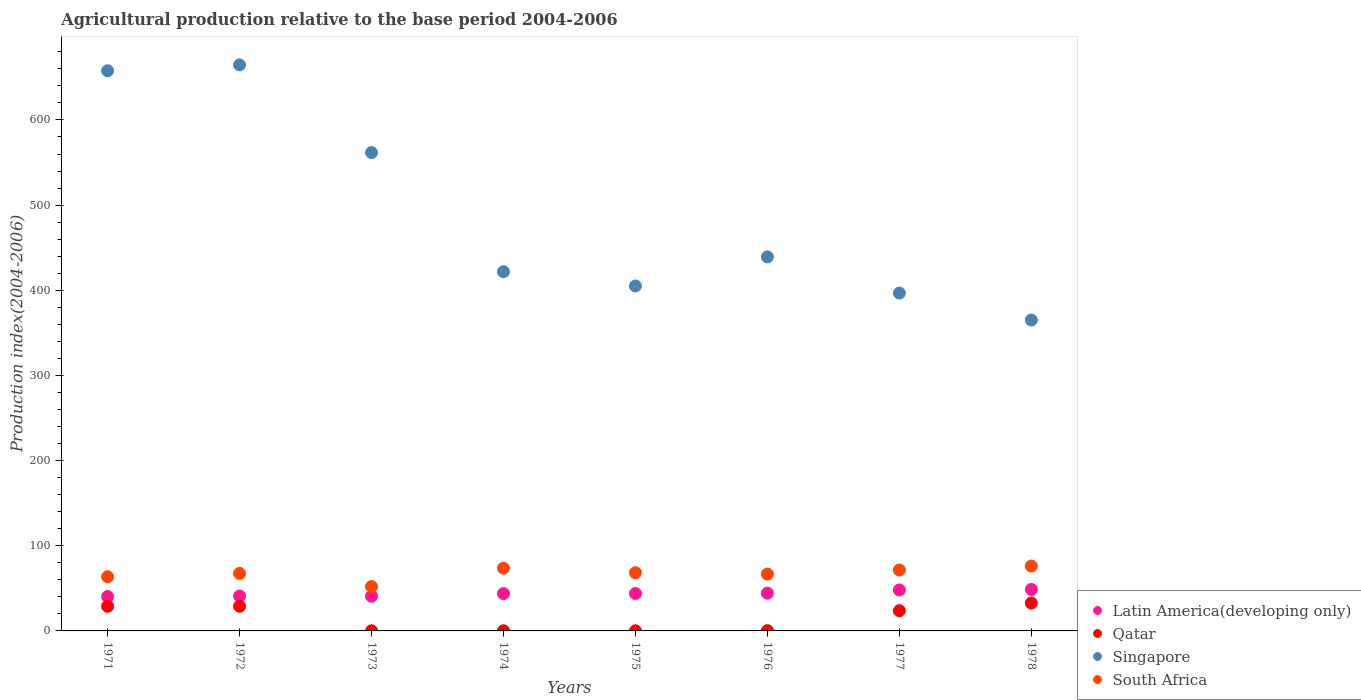How many different coloured dotlines are there?
Give a very brief answer. 4. What is the agricultural production index in South Africa in 1976?
Your answer should be compact. 66.74. Across all years, what is the maximum agricultural production index in Qatar?
Your response must be concise. 32.77. Across all years, what is the minimum agricultural production index in Latin America(developing only)?
Give a very brief answer. 40.36. In which year was the agricultural production index in Qatar maximum?
Provide a succinct answer. 1978. In which year was the agricultural production index in Latin America(developing only) minimum?
Offer a very short reply. 1971. What is the total agricultural production index in Qatar in the graph?
Your response must be concise. 115.3. What is the difference between the agricultural production index in Qatar in 1975 and that in 1978?
Offer a very short reply. -32.57. What is the difference between the agricultural production index in Latin America(developing only) in 1976 and the agricultural production index in Qatar in 1974?
Provide a short and direct response. 44.18. What is the average agricultural production index in Singapore per year?
Offer a very short reply. 489.01. In the year 1972, what is the difference between the agricultural production index in Qatar and agricultural production index in Latin America(developing only)?
Make the answer very short. -12. In how many years, is the agricultural production index in Latin America(developing only) greater than 460?
Your answer should be compact. 0. What is the ratio of the agricultural production index in Qatar in 1971 to that in 1974?
Give a very brief answer. 152.11. Is the agricultural production index in South Africa in 1973 less than that in 1975?
Your answer should be very brief. Yes. Is the difference between the agricultural production index in Qatar in 1976 and 1977 greater than the difference between the agricultural production index in Latin America(developing only) in 1976 and 1977?
Keep it short and to the point. No. What is the difference between the highest and the second highest agricultural production index in Singapore?
Your answer should be very brief. 6.91. What is the difference between the highest and the lowest agricultural production index in Latin America(developing only)?
Provide a short and direct response. 8.34. In how many years, is the agricultural production index in Latin America(developing only) greater than the average agricultural production index in Latin America(developing only) taken over all years?
Offer a terse response. 4. Is it the case that in every year, the sum of the agricultural production index in Qatar and agricultural production index in South Africa  is greater than the sum of agricultural production index in Latin America(developing only) and agricultural production index in Singapore?
Ensure brevity in your answer.  No. Is it the case that in every year, the sum of the agricultural production index in South Africa and agricultural production index in Qatar  is greater than the agricultural production index in Latin America(developing only)?
Make the answer very short. Yes. Does the agricultural production index in Qatar monotonically increase over the years?
Offer a terse response. No. How many years are there in the graph?
Keep it short and to the point. 8. What is the difference between two consecutive major ticks on the Y-axis?
Your response must be concise. 100. How many legend labels are there?
Your answer should be compact. 4. What is the title of the graph?
Provide a short and direct response. Agricultural production relative to the base period 2004-2006. Does "Serbia" appear as one of the legend labels in the graph?
Your answer should be very brief. No. What is the label or title of the Y-axis?
Your response must be concise. Production index(2004-2006). What is the Production index(2004-2006) in Latin America(developing only) in 1971?
Give a very brief answer. 40.36. What is the Production index(2004-2006) in Qatar in 1971?
Your answer should be compact. 28.9. What is the Production index(2004-2006) in Singapore in 1971?
Your answer should be compact. 657.79. What is the Production index(2004-2006) of South Africa in 1971?
Offer a terse response. 63.62. What is the Production index(2004-2006) of Latin America(developing only) in 1972?
Your response must be concise. 40.94. What is the Production index(2004-2006) of Qatar in 1972?
Give a very brief answer. 28.94. What is the Production index(2004-2006) of Singapore in 1972?
Offer a very short reply. 664.7. What is the Production index(2004-2006) of South Africa in 1972?
Your response must be concise. 67.57. What is the Production index(2004-2006) of Latin America(developing only) in 1973?
Offer a very short reply. 40.71. What is the Production index(2004-2006) of Qatar in 1973?
Provide a short and direct response. 0.17. What is the Production index(2004-2006) of Singapore in 1973?
Offer a very short reply. 561.67. What is the Production index(2004-2006) in South Africa in 1973?
Ensure brevity in your answer.  52.07. What is the Production index(2004-2006) of Latin America(developing only) in 1974?
Provide a succinct answer. 43.78. What is the Production index(2004-2006) of Qatar in 1974?
Make the answer very short. 0.19. What is the Production index(2004-2006) of Singapore in 1974?
Offer a terse response. 421.81. What is the Production index(2004-2006) of South Africa in 1974?
Provide a short and direct response. 73.67. What is the Production index(2004-2006) of Latin America(developing only) in 1975?
Your answer should be compact. 43.99. What is the Production index(2004-2006) of Singapore in 1975?
Offer a terse response. 405.08. What is the Production index(2004-2006) of South Africa in 1975?
Offer a terse response. 68.36. What is the Production index(2004-2006) in Latin America(developing only) in 1976?
Give a very brief answer. 44.37. What is the Production index(2004-2006) of Qatar in 1976?
Provide a short and direct response. 0.36. What is the Production index(2004-2006) of Singapore in 1976?
Provide a succinct answer. 439.22. What is the Production index(2004-2006) in South Africa in 1976?
Keep it short and to the point. 66.74. What is the Production index(2004-2006) of Latin America(developing only) in 1977?
Offer a terse response. 48.1. What is the Production index(2004-2006) of Qatar in 1977?
Offer a terse response. 23.77. What is the Production index(2004-2006) in Singapore in 1977?
Keep it short and to the point. 396.72. What is the Production index(2004-2006) of South Africa in 1977?
Your answer should be very brief. 71.51. What is the Production index(2004-2006) of Latin America(developing only) in 1978?
Keep it short and to the point. 48.69. What is the Production index(2004-2006) of Qatar in 1978?
Provide a succinct answer. 32.77. What is the Production index(2004-2006) of Singapore in 1978?
Your answer should be compact. 365.07. What is the Production index(2004-2006) in South Africa in 1978?
Ensure brevity in your answer.  76.16. Across all years, what is the maximum Production index(2004-2006) in Latin America(developing only)?
Provide a short and direct response. 48.69. Across all years, what is the maximum Production index(2004-2006) of Qatar?
Your answer should be very brief. 32.77. Across all years, what is the maximum Production index(2004-2006) of Singapore?
Ensure brevity in your answer.  664.7. Across all years, what is the maximum Production index(2004-2006) of South Africa?
Offer a terse response. 76.16. Across all years, what is the minimum Production index(2004-2006) of Latin America(developing only)?
Give a very brief answer. 40.36. Across all years, what is the minimum Production index(2004-2006) in Qatar?
Provide a short and direct response. 0.17. Across all years, what is the minimum Production index(2004-2006) in Singapore?
Your answer should be compact. 365.07. Across all years, what is the minimum Production index(2004-2006) of South Africa?
Your answer should be very brief. 52.07. What is the total Production index(2004-2006) in Latin America(developing only) in the graph?
Provide a short and direct response. 350.93. What is the total Production index(2004-2006) of Qatar in the graph?
Ensure brevity in your answer.  115.3. What is the total Production index(2004-2006) in Singapore in the graph?
Offer a terse response. 3912.06. What is the total Production index(2004-2006) of South Africa in the graph?
Your answer should be very brief. 539.7. What is the difference between the Production index(2004-2006) in Latin America(developing only) in 1971 and that in 1972?
Keep it short and to the point. -0.59. What is the difference between the Production index(2004-2006) of Qatar in 1971 and that in 1972?
Your answer should be compact. -0.04. What is the difference between the Production index(2004-2006) in Singapore in 1971 and that in 1972?
Make the answer very short. -6.91. What is the difference between the Production index(2004-2006) in South Africa in 1971 and that in 1972?
Ensure brevity in your answer.  -3.95. What is the difference between the Production index(2004-2006) of Latin America(developing only) in 1971 and that in 1973?
Make the answer very short. -0.35. What is the difference between the Production index(2004-2006) in Qatar in 1971 and that in 1973?
Make the answer very short. 28.73. What is the difference between the Production index(2004-2006) of Singapore in 1971 and that in 1973?
Your answer should be compact. 96.12. What is the difference between the Production index(2004-2006) of South Africa in 1971 and that in 1973?
Keep it short and to the point. 11.55. What is the difference between the Production index(2004-2006) in Latin America(developing only) in 1971 and that in 1974?
Offer a very short reply. -3.42. What is the difference between the Production index(2004-2006) in Qatar in 1971 and that in 1974?
Offer a very short reply. 28.71. What is the difference between the Production index(2004-2006) of Singapore in 1971 and that in 1974?
Give a very brief answer. 235.98. What is the difference between the Production index(2004-2006) of South Africa in 1971 and that in 1974?
Provide a short and direct response. -10.05. What is the difference between the Production index(2004-2006) of Latin America(developing only) in 1971 and that in 1975?
Offer a very short reply. -3.64. What is the difference between the Production index(2004-2006) of Qatar in 1971 and that in 1975?
Provide a succinct answer. 28.7. What is the difference between the Production index(2004-2006) of Singapore in 1971 and that in 1975?
Your answer should be very brief. 252.71. What is the difference between the Production index(2004-2006) in South Africa in 1971 and that in 1975?
Offer a terse response. -4.74. What is the difference between the Production index(2004-2006) in Latin America(developing only) in 1971 and that in 1976?
Offer a terse response. -4.01. What is the difference between the Production index(2004-2006) in Qatar in 1971 and that in 1976?
Your response must be concise. 28.54. What is the difference between the Production index(2004-2006) in Singapore in 1971 and that in 1976?
Offer a terse response. 218.57. What is the difference between the Production index(2004-2006) of South Africa in 1971 and that in 1976?
Offer a very short reply. -3.12. What is the difference between the Production index(2004-2006) in Latin America(developing only) in 1971 and that in 1977?
Provide a short and direct response. -7.74. What is the difference between the Production index(2004-2006) of Qatar in 1971 and that in 1977?
Your answer should be very brief. 5.13. What is the difference between the Production index(2004-2006) in Singapore in 1971 and that in 1977?
Keep it short and to the point. 261.07. What is the difference between the Production index(2004-2006) of South Africa in 1971 and that in 1977?
Give a very brief answer. -7.89. What is the difference between the Production index(2004-2006) in Latin America(developing only) in 1971 and that in 1978?
Ensure brevity in your answer.  -8.34. What is the difference between the Production index(2004-2006) of Qatar in 1971 and that in 1978?
Your response must be concise. -3.87. What is the difference between the Production index(2004-2006) in Singapore in 1971 and that in 1978?
Offer a very short reply. 292.72. What is the difference between the Production index(2004-2006) of South Africa in 1971 and that in 1978?
Your response must be concise. -12.54. What is the difference between the Production index(2004-2006) of Latin America(developing only) in 1972 and that in 1973?
Ensure brevity in your answer.  0.24. What is the difference between the Production index(2004-2006) of Qatar in 1972 and that in 1973?
Ensure brevity in your answer.  28.77. What is the difference between the Production index(2004-2006) of Singapore in 1972 and that in 1973?
Offer a very short reply. 103.03. What is the difference between the Production index(2004-2006) in Latin America(developing only) in 1972 and that in 1974?
Give a very brief answer. -2.83. What is the difference between the Production index(2004-2006) in Qatar in 1972 and that in 1974?
Ensure brevity in your answer.  28.75. What is the difference between the Production index(2004-2006) in Singapore in 1972 and that in 1974?
Ensure brevity in your answer.  242.89. What is the difference between the Production index(2004-2006) of South Africa in 1972 and that in 1974?
Keep it short and to the point. -6.1. What is the difference between the Production index(2004-2006) of Latin America(developing only) in 1972 and that in 1975?
Provide a short and direct response. -3.05. What is the difference between the Production index(2004-2006) of Qatar in 1972 and that in 1975?
Give a very brief answer. 28.74. What is the difference between the Production index(2004-2006) of Singapore in 1972 and that in 1975?
Ensure brevity in your answer.  259.62. What is the difference between the Production index(2004-2006) in South Africa in 1972 and that in 1975?
Ensure brevity in your answer.  -0.79. What is the difference between the Production index(2004-2006) of Latin America(developing only) in 1972 and that in 1976?
Keep it short and to the point. -3.42. What is the difference between the Production index(2004-2006) of Qatar in 1972 and that in 1976?
Give a very brief answer. 28.58. What is the difference between the Production index(2004-2006) of Singapore in 1972 and that in 1976?
Make the answer very short. 225.48. What is the difference between the Production index(2004-2006) of South Africa in 1972 and that in 1976?
Give a very brief answer. 0.83. What is the difference between the Production index(2004-2006) in Latin America(developing only) in 1972 and that in 1977?
Your response must be concise. -7.16. What is the difference between the Production index(2004-2006) in Qatar in 1972 and that in 1977?
Keep it short and to the point. 5.17. What is the difference between the Production index(2004-2006) in Singapore in 1972 and that in 1977?
Your answer should be compact. 267.98. What is the difference between the Production index(2004-2006) in South Africa in 1972 and that in 1977?
Your answer should be compact. -3.94. What is the difference between the Production index(2004-2006) in Latin America(developing only) in 1972 and that in 1978?
Make the answer very short. -7.75. What is the difference between the Production index(2004-2006) of Qatar in 1972 and that in 1978?
Make the answer very short. -3.83. What is the difference between the Production index(2004-2006) in Singapore in 1972 and that in 1978?
Give a very brief answer. 299.63. What is the difference between the Production index(2004-2006) in South Africa in 1972 and that in 1978?
Make the answer very short. -8.59. What is the difference between the Production index(2004-2006) in Latin America(developing only) in 1973 and that in 1974?
Provide a short and direct response. -3.07. What is the difference between the Production index(2004-2006) of Qatar in 1973 and that in 1974?
Ensure brevity in your answer.  -0.02. What is the difference between the Production index(2004-2006) in Singapore in 1973 and that in 1974?
Your response must be concise. 139.86. What is the difference between the Production index(2004-2006) of South Africa in 1973 and that in 1974?
Provide a succinct answer. -21.6. What is the difference between the Production index(2004-2006) of Latin America(developing only) in 1973 and that in 1975?
Provide a short and direct response. -3.28. What is the difference between the Production index(2004-2006) of Qatar in 1973 and that in 1975?
Make the answer very short. -0.03. What is the difference between the Production index(2004-2006) in Singapore in 1973 and that in 1975?
Ensure brevity in your answer.  156.59. What is the difference between the Production index(2004-2006) of South Africa in 1973 and that in 1975?
Offer a terse response. -16.29. What is the difference between the Production index(2004-2006) in Latin America(developing only) in 1973 and that in 1976?
Your answer should be very brief. -3.66. What is the difference between the Production index(2004-2006) in Qatar in 1973 and that in 1976?
Provide a short and direct response. -0.19. What is the difference between the Production index(2004-2006) in Singapore in 1973 and that in 1976?
Your response must be concise. 122.45. What is the difference between the Production index(2004-2006) in South Africa in 1973 and that in 1976?
Keep it short and to the point. -14.67. What is the difference between the Production index(2004-2006) of Latin America(developing only) in 1973 and that in 1977?
Make the answer very short. -7.39. What is the difference between the Production index(2004-2006) of Qatar in 1973 and that in 1977?
Provide a short and direct response. -23.6. What is the difference between the Production index(2004-2006) in Singapore in 1973 and that in 1977?
Your answer should be compact. 164.95. What is the difference between the Production index(2004-2006) of South Africa in 1973 and that in 1977?
Provide a short and direct response. -19.44. What is the difference between the Production index(2004-2006) of Latin America(developing only) in 1973 and that in 1978?
Make the answer very short. -7.99. What is the difference between the Production index(2004-2006) in Qatar in 1973 and that in 1978?
Your response must be concise. -32.6. What is the difference between the Production index(2004-2006) of Singapore in 1973 and that in 1978?
Give a very brief answer. 196.6. What is the difference between the Production index(2004-2006) in South Africa in 1973 and that in 1978?
Offer a very short reply. -24.09. What is the difference between the Production index(2004-2006) of Latin America(developing only) in 1974 and that in 1975?
Offer a very short reply. -0.22. What is the difference between the Production index(2004-2006) in Qatar in 1974 and that in 1975?
Provide a succinct answer. -0.01. What is the difference between the Production index(2004-2006) of Singapore in 1974 and that in 1975?
Your answer should be compact. 16.73. What is the difference between the Production index(2004-2006) in South Africa in 1974 and that in 1975?
Provide a succinct answer. 5.31. What is the difference between the Production index(2004-2006) of Latin America(developing only) in 1974 and that in 1976?
Your response must be concise. -0.59. What is the difference between the Production index(2004-2006) in Qatar in 1974 and that in 1976?
Keep it short and to the point. -0.17. What is the difference between the Production index(2004-2006) of Singapore in 1974 and that in 1976?
Offer a terse response. -17.41. What is the difference between the Production index(2004-2006) in South Africa in 1974 and that in 1976?
Give a very brief answer. 6.93. What is the difference between the Production index(2004-2006) of Latin America(developing only) in 1974 and that in 1977?
Give a very brief answer. -4.32. What is the difference between the Production index(2004-2006) of Qatar in 1974 and that in 1977?
Offer a very short reply. -23.58. What is the difference between the Production index(2004-2006) in Singapore in 1974 and that in 1977?
Provide a succinct answer. 25.09. What is the difference between the Production index(2004-2006) in South Africa in 1974 and that in 1977?
Your response must be concise. 2.16. What is the difference between the Production index(2004-2006) of Latin America(developing only) in 1974 and that in 1978?
Provide a short and direct response. -4.92. What is the difference between the Production index(2004-2006) in Qatar in 1974 and that in 1978?
Ensure brevity in your answer.  -32.58. What is the difference between the Production index(2004-2006) in Singapore in 1974 and that in 1978?
Provide a short and direct response. 56.74. What is the difference between the Production index(2004-2006) in South Africa in 1974 and that in 1978?
Your answer should be very brief. -2.49. What is the difference between the Production index(2004-2006) of Latin America(developing only) in 1975 and that in 1976?
Give a very brief answer. -0.37. What is the difference between the Production index(2004-2006) of Qatar in 1975 and that in 1976?
Ensure brevity in your answer.  -0.16. What is the difference between the Production index(2004-2006) in Singapore in 1975 and that in 1976?
Ensure brevity in your answer.  -34.14. What is the difference between the Production index(2004-2006) of South Africa in 1975 and that in 1976?
Make the answer very short. 1.62. What is the difference between the Production index(2004-2006) in Latin America(developing only) in 1975 and that in 1977?
Your response must be concise. -4.11. What is the difference between the Production index(2004-2006) of Qatar in 1975 and that in 1977?
Offer a very short reply. -23.57. What is the difference between the Production index(2004-2006) of Singapore in 1975 and that in 1977?
Offer a terse response. 8.36. What is the difference between the Production index(2004-2006) in South Africa in 1975 and that in 1977?
Ensure brevity in your answer.  -3.15. What is the difference between the Production index(2004-2006) in Latin America(developing only) in 1975 and that in 1978?
Make the answer very short. -4.7. What is the difference between the Production index(2004-2006) of Qatar in 1975 and that in 1978?
Your response must be concise. -32.57. What is the difference between the Production index(2004-2006) in Singapore in 1975 and that in 1978?
Make the answer very short. 40.01. What is the difference between the Production index(2004-2006) of South Africa in 1975 and that in 1978?
Your answer should be compact. -7.8. What is the difference between the Production index(2004-2006) of Latin America(developing only) in 1976 and that in 1977?
Provide a succinct answer. -3.73. What is the difference between the Production index(2004-2006) of Qatar in 1976 and that in 1977?
Offer a terse response. -23.41. What is the difference between the Production index(2004-2006) in Singapore in 1976 and that in 1977?
Provide a succinct answer. 42.5. What is the difference between the Production index(2004-2006) of South Africa in 1976 and that in 1977?
Give a very brief answer. -4.77. What is the difference between the Production index(2004-2006) of Latin America(developing only) in 1976 and that in 1978?
Offer a very short reply. -4.33. What is the difference between the Production index(2004-2006) in Qatar in 1976 and that in 1978?
Your answer should be compact. -32.41. What is the difference between the Production index(2004-2006) in Singapore in 1976 and that in 1978?
Offer a very short reply. 74.15. What is the difference between the Production index(2004-2006) in South Africa in 1976 and that in 1978?
Keep it short and to the point. -9.42. What is the difference between the Production index(2004-2006) in Latin America(developing only) in 1977 and that in 1978?
Make the answer very short. -0.6. What is the difference between the Production index(2004-2006) of Singapore in 1977 and that in 1978?
Provide a succinct answer. 31.65. What is the difference between the Production index(2004-2006) in South Africa in 1977 and that in 1978?
Offer a very short reply. -4.65. What is the difference between the Production index(2004-2006) of Latin America(developing only) in 1971 and the Production index(2004-2006) of Qatar in 1972?
Keep it short and to the point. 11.42. What is the difference between the Production index(2004-2006) of Latin America(developing only) in 1971 and the Production index(2004-2006) of Singapore in 1972?
Ensure brevity in your answer.  -624.34. What is the difference between the Production index(2004-2006) in Latin America(developing only) in 1971 and the Production index(2004-2006) in South Africa in 1972?
Provide a short and direct response. -27.21. What is the difference between the Production index(2004-2006) in Qatar in 1971 and the Production index(2004-2006) in Singapore in 1972?
Provide a short and direct response. -635.8. What is the difference between the Production index(2004-2006) in Qatar in 1971 and the Production index(2004-2006) in South Africa in 1972?
Your response must be concise. -38.67. What is the difference between the Production index(2004-2006) of Singapore in 1971 and the Production index(2004-2006) of South Africa in 1972?
Your answer should be very brief. 590.22. What is the difference between the Production index(2004-2006) of Latin America(developing only) in 1971 and the Production index(2004-2006) of Qatar in 1973?
Make the answer very short. 40.19. What is the difference between the Production index(2004-2006) in Latin America(developing only) in 1971 and the Production index(2004-2006) in Singapore in 1973?
Your answer should be compact. -521.31. What is the difference between the Production index(2004-2006) of Latin America(developing only) in 1971 and the Production index(2004-2006) of South Africa in 1973?
Offer a very short reply. -11.71. What is the difference between the Production index(2004-2006) in Qatar in 1971 and the Production index(2004-2006) in Singapore in 1973?
Ensure brevity in your answer.  -532.77. What is the difference between the Production index(2004-2006) of Qatar in 1971 and the Production index(2004-2006) of South Africa in 1973?
Make the answer very short. -23.17. What is the difference between the Production index(2004-2006) in Singapore in 1971 and the Production index(2004-2006) in South Africa in 1973?
Make the answer very short. 605.72. What is the difference between the Production index(2004-2006) in Latin America(developing only) in 1971 and the Production index(2004-2006) in Qatar in 1974?
Keep it short and to the point. 40.17. What is the difference between the Production index(2004-2006) in Latin America(developing only) in 1971 and the Production index(2004-2006) in Singapore in 1974?
Your response must be concise. -381.45. What is the difference between the Production index(2004-2006) of Latin America(developing only) in 1971 and the Production index(2004-2006) of South Africa in 1974?
Keep it short and to the point. -33.31. What is the difference between the Production index(2004-2006) in Qatar in 1971 and the Production index(2004-2006) in Singapore in 1974?
Offer a terse response. -392.91. What is the difference between the Production index(2004-2006) in Qatar in 1971 and the Production index(2004-2006) in South Africa in 1974?
Provide a succinct answer. -44.77. What is the difference between the Production index(2004-2006) in Singapore in 1971 and the Production index(2004-2006) in South Africa in 1974?
Give a very brief answer. 584.12. What is the difference between the Production index(2004-2006) in Latin America(developing only) in 1971 and the Production index(2004-2006) in Qatar in 1975?
Your response must be concise. 40.16. What is the difference between the Production index(2004-2006) of Latin America(developing only) in 1971 and the Production index(2004-2006) of Singapore in 1975?
Provide a succinct answer. -364.72. What is the difference between the Production index(2004-2006) in Latin America(developing only) in 1971 and the Production index(2004-2006) in South Africa in 1975?
Your answer should be very brief. -28. What is the difference between the Production index(2004-2006) of Qatar in 1971 and the Production index(2004-2006) of Singapore in 1975?
Your response must be concise. -376.18. What is the difference between the Production index(2004-2006) of Qatar in 1971 and the Production index(2004-2006) of South Africa in 1975?
Offer a very short reply. -39.46. What is the difference between the Production index(2004-2006) of Singapore in 1971 and the Production index(2004-2006) of South Africa in 1975?
Make the answer very short. 589.43. What is the difference between the Production index(2004-2006) in Latin America(developing only) in 1971 and the Production index(2004-2006) in Qatar in 1976?
Make the answer very short. 40. What is the difference between the Production index(2004-2006) of Latin America(developing only) in 1971 and the Production index(2004-2006) of Singapore in 1976?
Keep it short and to the point. -398.86. What is the difference between the Production index(2004-2006) in Latin America(developing only) in 1971 and the Production index(2004-2006) in South Africa in 1976?
Offer a terse response. -26.38. What is the difference between the Production index(2004-2006) of Qatar in 1971 and the Production index(2004-2006) of Singapore in 1976?
Keep it short and to the point. -410.32. What is the difference between the Production index(2004-2006) in Qatar in 1971 and the Production index(2004-2006) in South Africa in 1976?
Ensure brevity in your answer.  -37.84. What is the difference between the Production index(2004-2006) in Singapore in 1971 and the Production index(2004-2006) in South Africa in 1976?
Offer a terse response. 591.05. What is the difference between the Production index(2004-2006) in Latin America(developing only) in 1971 and the Production index(2004-2006) in Qatar in 1977?
Your answer should be compact. 16.59. What is the difference between the Production index(2004-2006) in Latin America(developing only) in 1971 and the Production index(2004-2006) in Singapore in 1977?
Offer a terse response. -356.36. What is the difference between the Production index(2004-2006) of Latin America(developing only) in 1971 and the Production index(2004-2006) of South Africa in 1977?
Provide a short and direct response. -31.15. What is the difference between the Production index(2004-2006) of Qatar in 1971 and the Production index(2004-2006) of Singapore in 1977?
Keep it short and to the point. -367.82. What is the difference between the Production index(2004-2006) of Qatar in 1971 and the Production index(2004-2006) of South Africa in 1977?
Make the answer very short. -42.61. What is the difference between the Production index(2004-2006) in Singapore in 1971 and the Production index(2004-2006) in South Africa in 1977?
Make the answer very short. 586.28. What is the difference between the Production index(2004-2006) in Latin America(developing only) in 1971 and the Production index(2004-2006) in Qatar in 1978?
Provide a succinct answer. 7.59. What is the difference between the Production index(2004-2006) of Latin America(developing only) in 1971 and the Production index(2004-2006) of Singapore in 1978?
Give a very brief answer. -324.71. What is the difference between the Production index(2004-2006) in Latin America(developing only) in 1971 and the Production index(2004-2006) in South Africa in 1978?
Ensure brevity in your answer.  -35.8. What is the difference between the Production index(2004-2006) in Qatar in 1971 and the Production index(2004-2006) in Singapore in 1978?
Make the answer very short. -336.17. What is the difference between the Production index(2004-2006) in Qatar in 1971 and the Production index(2004-2006) in South Africa in 1978?
Provide a short and direct response. -47.26. What is the difference between the Production index(2004-2006) in Singapore in 1971 and the Production index(2004-2006) in South Africa in 1978?
Your response must be concise. 581.63. What is the difference between the Production index(2004-2006) in Latin America(developing only) in 1972 and the Production index(2004-2006) in Qatar in 1973?
Give a very brief answer. 40.77. What is the difference between the Production index(2004-2006) of Latin America(developing only) in 1972 and the Production index(2004-2006) of Singapore in 1973?
Offer a very short reply. -520.73. What is the difference between the Production index(2004-2006) in Latin America(developing only) in 1972 and the Production index(2004-2006) in South Africa in 1973?
Give a very brief answer. -11.13. What is the difference between the Production index(2004-2006) in Qatar in 1972 and the Production index(2004-2006) in Singapore in 1973?
Your answer should be very brief. -532.73. What is the difference between the Production index(2004-2006) of Qatar in 1972 and the Production index(2004-2006) of South Africa in 1973?
Your answer should be compact. -23.13. What is the difference between the Production index(2004-2006) of Singapore in 1972 and the Production index(2004-2006) of South Africa in 1973?
Give a very brief answer. 612.63. What is the difference between the Production index(2004-2006) in Latin America(developing only) in 1972 and the Production index(2004-2006) in Qatar in 1974?
Provide a succinct answer. 40.75. What is the difference between the Production index(2004-2006) in Latin America(developing only) in 1972 and the Production index(2004-2006) in Singapore in 1974?
Your response must be concise. -380.87. What is the difference between the Production index(2004-2006) in Latin America(developing only) in 1972 and the Production index(2004-2006) in South Africa in 1974?
Give a very brief answer. -32.73. What is the difference between the Production index(2004-2006) of Qatar in 1972 and the Production index(2004-2006) of Singapore in 1974?
Your answer should be very brief. -392.87. What is the difference between the Production index(2004-2006) of Qatar in 1972 and the Production index(2004-2006) of South Africa in 1974?
Your answer should be very brief. -44.73. What is the difference between the Production index(2004-2006) of Singapore in 1972 and the Production index(2004-2006) of South Africa in 1974?
Your answer should be compact. 591.03. What is the difference between the Production index(2004-2006) of Latin America(developing only) in 1972 and the Production index(2004-2006) of Qatar in 1975?
Give a very brief answer. 40.74. What is the difference between the Production index(2004-2006) in Latin America(developing only) in 1972 and the Production index(2004-2006) in Singapore in 1975?
Provide a succinct answer. -364.14. What is the difference between the Production index(2004-2006) in Latin America(developing only) in 1972 and the Production index(2004-2006) in South Africa in 1975?
Your answer should be very brief. -27.42. What is the difference between the Production index(2004-2006) in Qatar in 1972 and the Production index(2004-2006) in Singapore in 1975?
Provide a succinct answer. -376.14. What is the difference between the Production index(2004-2006) in Qatar in 1972 and the Production index(2004-2006) in South Africa in 1975?
Your answer should be compact. -39.42. What is the difference between the Production index(2004-2006) in Singapore in 1972 and the Production index(2004-2006) in South Africa in 1975?
Ensure brevity in your answer.  596.34. What is the difference between the Production index(2004-2006) of Latin America(developing only) in 1972 and the Production index(2004-2006) of Qatar in 1976?
Provide a short and direct response. 40.58. What is the difference between the Production index(2004-2006) of Latin America(developing only) in 1972 and the Production index(2004-2006) of Singapore in 1976?
Offer a terse response. -398.28. What is the difference between the Production index(2004-2006) in Latin America(developing only) in 1972 and the Production index(2004-2006) in South Africa in 1976?
Your answer should be very brief. -25.8. What is the difference between the Production index(2004-2006) of Qatar in 1972 and the Production index(2004-2006) of Singapore in 1976?
Offer a terse response. -410.28. What is the difference between the Production index(2004-2006) in Qatar in 1972 and the Production index(2004-2006) in South Africa in 1976?
Your response must be concise. -37.8. What is the difference between the Production index(2004-2006) in Singapore in 1972 and the Production index(2004-2006) in South Africa in 1976?
Make the answer very short. 597.96. What is the difference between the Production index(2004-2006) in Latin America(developing only) in 1972 and the Production index(2004-2006) in Qatar in 1977?
Your response must be concise. 17.17. What is the difference between the Production index(2004-2006) of Latin America(developing only) in 1972 and the Production index(2004-2006) of Singapore in 1977?
Give a very brief answer. -355.78. What is the difference between the Production index(2004-2006) in Latin America(developing only) in 1972 and the Production index(2004-2006) in South Africa in 1977?
Give a very brief answer. -30.57. What is the difference between the Production index(2004-2006) of Qatar in 1972 and the Production index(2004-2006) of Singapore in 1977?
Provide a succinct answer. -367.78. What is the difference between the Production index(2004-2006) in Qatar in 1972 and the Production index(2004-2006) in South Africa in 1977?
Give a very brief answer. -42.57. What is the difference between the Production index(2004-2006) of Singapore in 1972 and the Production index(2004-2006) of South Africa in 1977?
Your answer should be very brief. 593.19. What is the difference between the Production index(2004-2006) of Latin America(developing only) in 1972 and the Production index(2004-2006) of Qatar in 1978?
Keep it short and to the point. 8.17. What is the difference between the Production index(2004-2006) of Latin America(developing only) in 1972 and the Production index(2004-2006) of Singapore in 1978?
Your answer should be compact. -324.13. What is the difference between the Production index(2004-2006) in Latin America(developing only) in 1972 and the Production index(2004-2006) in South Africa in 1978?
Offer a terse response. -35.22. What is the difference between the Production index(2004-2006) in Qatar in 1972 and the Production index(2004-2006) in Singapore in 1978?
Offer a very short reply. -336.13. What is the difference between the Production index(2004-2006) of Qatar in 1972 and the Production index(2004-2006) of South Africa in 1978?
Offer a very short reply. -47.22. What is the difference between the Production index(2004-2006) of Singapore in 1972 and the Production index(2004-2006) of South Africa in 1978?
Your response must be concise. 588.54. What is the difference between the Production index(2004-2006) of Latin America(developing only) in 1973 and the Production index(2004-2006) of Qatar in 1974?
Give a very brief answer. 40.52. What is the difference between the Production index(2004-2006) of Latin America(developing only) in 1973 and the Production index(2004-2006) of Singapore in 1974?
Ensure brevity in your answer.  -381.1. What is the difference between the Production index(2004-2006) in Latin America(developing only) in 1973 and the Production index(2004-2006) in South Africa in 1974?
Provide a succinct answer. -32.96. What is the difference between the Production index(2004-2006) in Qatar in 1973 and the Production index(2004-2006) in Singapore in 1974?
Give a very brief answer. -421.64. What is the difference between the Production index(2004-2006) of Qatar in 1973 and the Production index(2004-2006) of South Africa in 1974?
Your answer should be very brief. -73.5. What is the difference between the Production index(2004-2006) of Singapore in 1973 and the Production index(2004-2006) of South Africa in 1974?
Provide a short and direct response. 488. What is the difference between the Production index(2004-2006) of Latin America(developing only) in 1973 and the Production index(2004-2006) of Qatar in 1975?
Offer a very short reply. 40.51. What is the difference between the Production index(2004-2006) in Latin America(developing only) in 1973 and the Production index(2004-2006) in Singapore in 1975?
Ensure brevity in your answer.  -364.37. What is the difference between the Production index(2004-2006) in Latin America(developing only) in 1973 and the Production index(2004-2006) in South Africa in 1975?
Ensure brevity in your answer.  -27.65. What is the difference between the Production index(2004-2006) in Qatar in 1973 and the Production index(2004-2006) in Singapore in 1975?
Ensure brevity in your answer.  -404.91. What is the difference between the Production index(2004-2006) in Qatar in 1973 and the Production index(2004-2006) in South Africa in 1975?
Offer a very short reply. -68.19. What is the difference between the Production index(2004-2006) in Singapore in 1973 and the Production index(2004-2006) in South Africa in 1975?
Provide a succinct answer. 493.31. What is the difference between the Production index(2004-2006) in Latin America(developing only) in 1973 and the Production index(2004-2006) in Qatar in 1976?
Ensure brevity in your answer.  40.35. What is the difference between the Production index(2004-2006) in Latin America(developing only) in 1973 and the Production index(2004-2006) in Singapore in 1976?
Offer a terse response. -398.51. What is the difference between the Production index(2004-2006) in Latin America(developing only) in 1973 and the Production index(2004-2006) in South Africa in 1976?
Provide a short and direct response. -26.03. What is the difference between the Production index(2004-2006) in Qatar in 1973 and the Production index(2004-2006) in Singapore in 1976?
Give a very brief answer. -439.05. What is the difference between the Production index(2004-2006) of Qatar in 1973 and the Production index(2004-2006) of South Africa in 1976?
Give a very brief answer. -66.57. What is the difference between the Production index(2004-2006) of Singapore in 1973 and the Production index(2004-2006) of South Africa in 1976?
Provide a succinct answer. 494.93. What is the difference between the Production index(2004-2006) of Latin America(developing only) in 1973 and the Production index(2004-2006) of Qatar in 1977?
Give a very brief answer. 16.94. What is the difference between the Production index(2004-2006) of Latin America(developing only) in 1973 and the Production index(2004-2006) of Singapore in 1977?
Keep it short and to the point. -356.01. What is the difference between the Production index(2004-2006) in Latin America(developing only) in 1973 and the Production index(2004-2006) in South Africa in 1977?
Offer a terse response. -30.8. What is the difference between the Production index(2004-2006) in Qatar in 1973 and the Production index(2004-2006) in Singapore in 1977?
Provide a succinct answer. -396.55. What is the difference between the Production index(2004-2006) of Qatar in 1973 and the Production index(2004-2006) of South Africa in 1977?
Your response must be concise. -71.34. What is the difference between the Production index(2004-2006) in Singapore in 1973 and the Production index(2004-2006) in South Africa in 1977?
Your response must be concise. 490.16. What is the difference between the Production index(2004-2006) of Latin America(developing only) in 1973 and the Production index(2004-2006) of Qatar in 1978?
Make the answer very short. 7.94. What is the difference between the Production index(2004-2006) of Latin America(developing only) in 1973 and the Production index(2004-2006) of Singapore in 1978?
Your answer should be very brief. -324.36. What is the difference between the Production index(2004-2006) of Latin America(developing only) in 1973 and the Production index(2004-2006) of South Africa in 1978?
Keep it short and to the point. -35.45. What is the difference between the Production index(2004-2006) of Qatar in 1973 and the Production index(2004-2006) of Singapore in 1978?
Your answer should be compact. -364.9. What is the difference between the Production index(2004-2006) in Qatar in 1973 and the Production index(2004-2006) in South Africa in 1978?
Make the answer very short. -75.99. What is the difference between the Production index(2004-2006) in Singapore in 1973 and the Production index(2004-2006) in South Africa in 1978?
Give a very brief answer. 485.51. What is the difference between the Production index(2004-2006) in Latin America(developing only) in 1974 and the Production index(2004-2006) in Qatar in 1975?
Make the answer very short. 43.58. What is the difference between the Production index(2004-2006) of Latin America(developing only) in 1974 and the Production index(2004-2006) of Singapore in 1975?
Provide a succinct answer. -361.3. What is the difference between the Production index(2004-2006) in Latin America(developing only) in 1974 and the Production index(2004-2006) in South Africa in 1975?
Your answer should be compact. -24.58. What is the difference between the Production index(2004-2006) in Qatar in 1974 and the Production index(2004-2006) in Singapore in 1975?
Provide a succinct answer. -404.89. What is the difference between the Production index(2004-2006) in Qatar in 1974 and the Production index(2004-2006) in South Africa in 1975?
Ensure brevity in your answer.  -68.17. What is the difference between the Production index(2004-2006) of Singapore in 1974 and the Production index(2004-2006) of South Africa in 1975?
Offer a very short reply. 353.45. What is the difference between the Production index(2004-2006) of Latin America(developing only) in 1974 and the Production index(2004-2006) of Qatar in 1976?
Give a very brief answer. 43.42. What is the difference between the Production index(2004-2006) of Latin America(developing only) in 1974 and the Production index(2004-2006) of Singapore in 1976?
Your answer should be compact. -395.44. What is the difference between the Production index(2004-2006) in Latin America(developing only) in 1974 and the Production index(2004-2006) in South Africa in 1976?
Keep it short and to the point. -22.96. What is the difference between the Production index(2004-2006) in Qatar in 1974 and the Production index(2004-2006) in Singapore in 1976?
Your answer should be very brief. -439.03. What is the difference between the Production index(2004-2006) of Qatar in 1974 and the Production index(2004-2006) of South Africa in 1976?
Provide a succinct answer. -66.55. What is the difference between the Production index(2004-2006) of Singapore in 1974 and the Production index(2004-2006) of South Africa in 1976?
Offer a terse response. 355.07. What is the difference between the Production index(2004-2006) in Latin America(developing only) in 1974 and the Production index(2004-2006) in Qatar in 1977?
Offer a very short reply. 20.01. What is the difference between the Production index(2004-2006) of Latin America(developing only) in 1974 and the Production index(2004-2006) of Singapore in 1977?
Ensure brevity in your answer.  -352.94. What is the difference between the Production index(2004-2006) in Latin America(developing only) in 1974 and the Production index(2004-2006) in South Africa in 1977?
Make the answer very short. -27.73. What is the difference between the Production index(2004-2006) of Qatar in 1974 and the Production index(2004-2006) of Singapore in 1977?
Keep it short and to the point. -396.53. What is the difference between the Production index(2004-2006) of Qatar in 1974 and the Production index(2004-2006) of South Africa in 1977?
Your answer should be compact. -71.32. What is the difference between the Production index(2004-2006) of Singapore in 1974 and the Production index(2004-2006) of South Africa in 1977?
Your answer should be very brief. 350.3. What is the difference between the Production index(2004-2006) of Latin America(developing only) in 1974 and the Production index(2004-2006) of Qatar in 1978?
Your response must be concise. 11.01. What is the difference between the Production index(2004-2006) in Latin America(developing only) in 1974 and the Production index(2004-2006) in Singapore in 1978?
Offer a terse response. -321.29. What is the difference between the Production index(2004-2006) in Latin America(developing only) in 1974 and the Production index(2004-2006) in South Africa in 1978?
Provide a short and direct response. -32.38. What is the difference between the Production index(2004-2006) of Qatar in 1974 and the Production index(2004-2006) of Singapore in 1978?
Offer a very short reply. -364.88. What is the difference between the Production index(2004-2006) of Qatar in 1974 and the Production index(2004-2006) of South Africa in 1978?
Provide a short and direct response. -75.97. What is the difference between the Production index(2004-2006) in Singapore in 1974 and the Production index(2004-2006) in South Africa in 1978?
Give a very brief answer. 345.65. What is the difference between the Production index(2004-2006) of Latin America(developing only) in 1975 and the Production index(2004-2006) of Qatar in 1976?
Ensure brevity in your answer.  43.63. What is the difference between the Production index(2004-2006) in Latin America(developing only) in 1975 and the Production index(2004-2006) in Singapore in 1976?
Offer a terse response. -395.23. What is the difference between the Production index(2004-2006) in Latin America(developing only) in 1975 and the Production index(2004-2006) in South Africa in 1976?
Offer a very short reply. -22.75. What is the difference between the Production index(2004-2006) in Qatar in 1975 and the Production index(2004-2006) in Singapore in 1976?
Provide a short and direct response. -439.02. What is the difference between the Production index(2004-2006) of Qatar in 1975 and the Production index(2004-2006) of South Africa in 1976?
Your answer should be very brief. -66.54. What is the difference between the Production index(2004-2006) in Singapore in 1975 and the Production index(2004-2006) in South Africa in 1976?
Your response must be concise. 338.34. What is the difference between the Production index(2004-2006) of Latin America(developing only) in 1975 and the Production index(2004-2006) of Qatar in 1977?
Your answer should be very brief. 20.22. What is the difference between the Production index(2004-2006) of Latin America(developing only) in 1975 and the Production index(2004-2006) of Singapore in 1977?
Your response must be concise. -352.73. What is the difference between the Production index(2004-2006) of Latin America(developing only) in 1975 and the Production index(2004-2006) of South Africa in 1977?
Give a very brief answer. -27.52. What is the difference between the Production index(2004-2006) of Qatar in 1975 and the Production index(2004-2006) of Singapore in 1977?
Make the answer very short. -396.52. What is the difference between the Production index(2004-2006) in Qatar in 1975 and the Production index(2004-2006) in South Africa in 1977?
Provide a succinct answer. -71.31. What is the difference between the Production index(2004-2006) of Singapore in 1975 and the Production index(2004-2006) of South Africa in 1977?
Provide a succinct answer. 333.57. What is the difference between the Production index(2004-2006) of Latin America(developing only) in 1975 and the Production index(2004-2006) of Qatar in 1978?
Offer a very short reply. 11.22. What is the difference between the Production index(2004-2006) of Latin America(developing only) in 1975 and the Production index(2004-2006) of Singapore in 1978?
Keep it short and to the point. -321.08. What is the difference between the Production index(2004-2006) in Latin America(developing only) in 1975 and the Production index(2004-2006) in South Africa in 1978?
Give a very brief answer. -32.17. What is the difference between the Production index(2004-2006) of Qatar in 1975 and the Production index(2004-2006) of Singapore in 1978?
Give a very brief answer. -364.87. What is the difference between the Production index(2004-2006) in Qatar in 1975 and the Production index(2004-2006) in South Africa in 1978?
Offer a terse response. -75.96. What is the difference between the Production index(2004-2006) of Singapore in 1975 and the Production index(2004-2006) of South Africa in 1978?
Provide a short and direct response. 328.92. What is the difference between the Production index(2004-2006) in Latin America(developing only) in 1976 and the Production index(2004-2006) in Qatar in 1977?
Ensure brevity in your answer.  20.6. What is the difference between the Production index(2004-2006) in Latin America(developing only) in 1976 and the Production index(2004-2006) in Singapore in 1977?
Make the answer very short. -352.35. What is the difference between the Production index(2004-2006) of Latin America(developing only) in 1976 and the Production index(2004-2006) of South Africa in 1977?
Offer a terse response. -27.14. What is the difference between the Production index(2004-2006) of Qatar in 1976 and the Production index(2004-2006) of Singapore in 1977?
Offer a terse response. -396.36. What is the difference between the Production index(2004-2006) in Qatar in 1976 and the Production index(2004-2006) in South Africa in 1977?
Offer a very short reply. -71.15. What is the difference between the Production index(2004-2006) in Singapore in 1976 and the Production index(2004-2006) in South Africa in 1977?
Ensure brevity in your answer.  367.71. What is the difference between the Production index(2004-2006) of Latin America(developing only) in 1976 and the Production index(2004-2006) of Qatar in 1978?
Your response must be concise. 11.6. What is the difference between the Production index(2004-2006) in Latin America(developing only) in 1976 and the Production index(2004-2006) in Singapore in 1978?
Provide a short and direct response. -320.7. What is the difference between the Production index(2004-2006) in Latin America(developing only) in 1976 and the Production index(2004-2006) in South Africa in 1978?
Keep it short and to the point. -31.79. What is the difference between the Production index(2004-2006) of Qatar in 1976 and the Production index(2004-2006) of Singapore in 1978?
Give a very brief answer. -364.71. What is the difference between the Production index(2004-2006) in Qatar in 1976 and the Production index(2004-2006) in South Africa in 1978?
Ensure brevity in your answer.  -75.8. What is the difference between the Production index(2004-2006) in Singapore in 1976 and the Production index(2004-2006) in South Africa in 1978?
Your response must be concise. 363.06. What is the difference between the Production index(2004-2006) of Latin America(developing only) in 1977 and the Production index(2004-2006) of Qatar in 1978?
Make the answer very short. 15.33. What is the difference between the Production index(2004-2006) in Latin America(developing only) in 1977 and the Production index(2004-2006) in Singapore in 1978?
Make the answer very short. -316.97. What is the difference between the Production index(2004-2006) of Latin America(developing only) in 1977 and the Production index(2004-2006) of South Africa in 1978?
Provide a succinct answer. -28.06. What is the difference between the Production index(2004-2006) in Qatar in 1977 and the Production index(2004-2006) in Singapore in 1978?
Your response must be concise. -341.3. What is the difference between the Production index(2004-2006) of Qatar in 1977 and the Production index(2004-2006) of South Africa in 1978?
Give a very brief answer. -52.39. What is the difference between the Production index(2004-2006) of Singapore in 1977 and the Production index(2004-2006) of South Africa in 1978?
Your answer should be compact. 320.56. What is the average Production index(2004-2006) in Latin America(developing only) per year?
Offer a very short reply. 43.87. What is the average Production index(2004-2006) in Qatar per year?
Make the answer very short. 14.41. What is the average Production index(2004-2006) in Singapore per year?
Make the answer very short. 489.01. What is the average Production index(2004-2006) of South Africa per year?
Offer a terse response. 67.46. In the year 1971, what is the difference between the Production index(2004-2006) of Latin America(developing only) and Production index(2004-2006) of Qatar?
Your answer should be compact. 11.46. In the year 1971, what is the difference between the Production index(2004-2006) in Latin America(developing only) and Production index(2004-2006) in Singapore?
Provide a short and direct response. -617.43. In the year 1971, what is the difference between the Production index(2004-2006) of Latin America(developing only) and Production index(2004-2006) of South Africa?
Provide a succinct answer. -23.26. In the year 1971, what is the difference between the Production index(2004-2006) in Qatar and Production index(2004-2006) in Singapore?
Give a very brief answer. -628.89. In the year 1971, what is the difference between the Production index(2004-2006) in Qatar and Production index(2004-2006) in South Africa?
Keep it short and to the point. -34.72. In the year 1971, what is the difference between the Production index(2004-2006) of Singapore and Production index(2004-2006) of South Africa?
Provide a succinct answer. 594.17. In the year 1972, what is the difference between the Production index(2004-2006) in Latin America(developing only) and Production index(2004-2006) in Qatar?
Make the answer very short. 12. In the year 1972, what is the difference between the Production index(2004-2006) in Latin America(developing only) and Production index(2004-2006) in Singapore?
Ensure brevity in your answer.  -623.76. In the year 1972, what is the difference between the Production index(2004-2006) of Latin America(developing only) and Production index(2004-2006) of South Africa?
Your answer should be compact. -26.63. In the year 1972, what is the difference between the Production index(2004-2006) of Qatar and Production index(2004-2006) of Singapore?
Your response must be concise. -635.76. In the year 1972, what is the difference between the Production index(2004-2006) of Qatar and Production index(2004-2006) of South Africa?
Provide a succinct answer. -38.63. In the year 1972, what is the difference between the Production index(2004-2006) of Singapore and Production index(2004-2006) of South Africa?
Provide a succinct answer. 597.13. In the year 1973, what is the difference between the Production index(2004-2006) in Latin America(developing only) and Production index(2004-2006) in Qatar?
Make the answer very short. 40.54. In the year 1973, what is the difference between the Production index(2004-2006) in Latin America(developing only) and Production index(2004-2006) in Singapore?
Ensure brevity in your answer.  -520.96. In the year 1973, what is the difference between the Production index(2004-2006) of Latin America(developing only) and Production index(2004-2006) of South Africa?
Your response must be concise. -11.36. In the year 1973, what is the difference between the Production index(2004-2006) of Qatar and Production index(2004-2006) of Singapore?
Give a very brief answer. -561.5. In the year 1973, what is the difference between the Production index(2004-2006) of Qatar and Production index(2004-2006) of South Africa?
Make the answer very short. -51.9. In the year 1973, what is the difference between the Production index(2004-2006) of Singapore and Production index(2004-2006) of South Africa?
Keep it short and to the point. 509.6. In the year 1974, what is the difference between the Production index(2004-2006) of Latin America(developing only) and Production index(2004-2006) of Qatar?
Offer a terse response. 43.59. In the year 1974, what is the difference between the Production index(2004-2006) in Latin America(developing only) and Production index(2004-2006) in Singapore?
Make the answer very short. -378.03. In the year 1974, what is the difference between the Production index(2004-2006) in Latin America(developing only) and Production index(2004-2006) in South Africa?
Ensure brevity in your answer.  -29.89. In the year 1974, what is the difference between the Production index(2004-2006) in Qatar and Production index(2004-2006) in Singapore?
Give a very brief answer. -421.62. In the year 1974, what is the difference between the Production index(2004-2006) in Qatar and Production index(2004-2006) in South Africa?
Ensure brevity in your answer.  -73.48. In the year 1974, what is the difference between the Production index(2004-2006) of Singapore and Production index(2004-2006) of South Africa?
Provide a short and direct response. 348.14. In the year 1975, what is the difference between the Production index(2004-2006) of Latin America(developing only) and Production index(2004-2006) of Qatar?
Give a very brief answer. 43.79. In the year 1975, what is the difference between the Production index(2004-2006) of Latin America(developing only) and Production index(2004-2006) of Singapore?
Ensure brevity in your answer.  -361.09. In the year 1975, what is the difference between the Production index(2004-2006) of Latin America(developing only) and Production index(2004-2006) of South Africa?
Offer a very short reply. -24.37. In the year 1975, what is the difference between the Production index(2004-2006) in Qatar and Production index(2004-2006) in Singapore?
Your answer should be compact. -404.88. In the year 1975, what is the difference between the Production index(2004-2006) of Qatar and Production index(2004-2006) of South Africa?
Ensure brevity in your answer.  -68.16. In the year 1975, what is the difference between the Production index(2004-2006) of Singapore and Production index(2004-2006) of South Africa?
Your answer should be very brief. 336.72. In the year 1976, what is the difference between the Production index(2004-2006) of Latin America(developing only) and Production index(2004-2006) of Qatar?
Keep it short and to the point. 44.01. In the year 1976, what is the difference between the Production index(2004-2006) in Latin America(developing only) and Production index(2004-2006) in Singapore?
Your response must be concise. -394.85. In the year 1976, what is the difference between the Production index(2004-2006) of Latin America(developing only) and Production index(2004-2006) of South Africa?
Ensure brevity in your answer.  -22.37. In the year 1976, what is the difference between the Production index(2004-2006) in Qatar and Production index(2004-2006) in Singapore?
Provide a short and direct response. -438.86. In the year 1976, what is the difference between the Production index(2004-2006) of Qatar and Production index(2004-2006) of South Africa?
Offer a terse response. -66.38. In the year 1976, what is the difference between the Production index(2004-2006) in Singapore and Production index(2004-2006) in South Africa?
Provide a succinct answer. 372.48. In the year 1977, what is the difference between the Production index(2004-2006) of Latin America(developing only) and Production index(2004-2006) of Qatar?
Your response must be concise. 24.33. In the year 1977, what is the difference between the Production index(2004-2006) in Latin America(developing only) and Production index(2004-2006) in Singapore?
Keep it short and to the point. -348.62. In the year 1977, what is the difference between the Production index(2004-2006) in Latin America(developing only) and Production index(2004-2006) in South Africa?
Offer a very short reply. -23.41. In the year 1977, what is the difference between the Production index(2004-2006) of Qatar and Production index(2004-2006) of Singapore?
Provide a short and direct response. -372.95. In the year 1977, what is the difference between the Production index(2004-2006) of Qatar and Production index(2004-2006) of South Africa?
Your response must be concise. -47.74. In the year 1977, what is the difference between the Production index(2004-2006) of Singapore and Production index(2004-2006) of South Africa?
Make the answer very short. 325.21. In the year 1978, what is the difference between the Production index(2004-2006) of Latin America(developing only) and Production index(2004-2006) of Qatar?
Provide a short and direct response. 15.92. In the year 1978, what is the difference between the Production index(2004-2006) in Latin America(developing only) and Production index(2004-2006) in Singapore?
Give a very brief answer. -316.38. In the year 1978, what is the difference between the Production index(2004-2006) in Latin America(developing only) and Production index(2004-2006) in South Africa?
Make the answer very short. -27.47. In the year 1978, what is the difference between the Production index(2004-2006) of Qatar and Production index(2004-2006) of Singapore?
Your answer should be very brief. -332.3. In the year 1978, what is the difference between the Production index(2004-2006) of Qatar and Production index(2004-2006) of South Africa?
Your answer should be very brief. -43.39. In the year 1978, what is the difference between the Production index(2004-2006) in Singapore and Production index(2004-2006) in South Africa?
Your answer should be compact. 288.91. What is the ratio of the Production index(2004-2006) in Latin America(developing only) in 1971 to that in 1972?
Offer a terse response. 0.99. What is the ratio of the Production index(2004-2006) of Singapore in 1971 to that in 1972?
Give a very brief answer. 0.99. What is the ratio of the Production index(2004-2006) in South Africa in 1971 to that in 1972?
Ensure brevity in your answer.  0.94. What is the ratio of the Production index(2004-2006) in Qatar in 1971 to that in 1973?
Ensure brevity in your answer.  170. What is the ratio of the Production index(2004-2006) in Singapore in 1971 to that in 1973?
Your answer should be compact. 1.17. What is the ratio of the Production index(2004-2006) of South Africa in 1971 to that in 1973?
Your response must be concise. 1.22. What is the ratio of the Production index(2004-2006) in Latin America(developing only) in 1971 to that in 1974?
Give a very brief answer. 0.92. What is the ratio of the Production index(2004-2006) of Qatar in 1971 to that in 1974?
Offer a very short reply. 152.11. What is the ratio of the Production index(2004-2006) of Singapore in 1971 to that in 1974?
Keep it short and to the point. 1.56. What is the ratio of the Production index(2004-2006) in South Africa in 1971 to that in 1974?
Make the answer very short. 0.86. What is the ratio of the Production index(2004-2006) of Latin America(developing only) in 1971 to that in 1975?
Your answer should be compact. 0.92. What is the ratio of the Production index(2004-2006) of Qatar in 1971 to that in 1975?
Offer a very short reply. 144.5. What is the ratio of the Production index(2004-2006) of Singapore in 1971 to that in 1975?
Provide a short and direct response. 1.62. What is the ratio of the Production index(2004-2006) in South Africa in 1971 to that in 1975?
Keep it short and to the point. 0.93. What is the ratio of the Production index(2004-2006) in Latin America(developing only) in 1971 to that in 1976?
Your answer should be compact. 0.91. What is the ratio of the Production index(2004-2006) in Qatar in 1971 to that in 1976?
Provide a short and direct response. 80.28. What is the ratio of the Production index(2004-2006) in Singapore in 1971 to that in 1976?
Provide a short and direct response. 1.5. What is the ratio of the Production index(2004-2006) in South Africa in 1971 to that in 1976?
Keep it short and to the point. 0.95. What is the ratio of the Production index(2004-2006) of Latin America(developing only) in 1971 to that in 1977?
Offer a terse response. 0.84. What is the ratio of the Production index(2004-2006) of Qatar in 1971 to that in 1977?
Offer a terse response. 1.22. What is the ratio of the Production index(2004-2006) of Singapore in 1971 to that in 1977?
Your answer should be compact. 1.66. What is the ratio of the Production index(2004-2006) of South Africa in 1971 to that in 1977?
Ensure brevity in your answer.  0.89. What is the ratio of the Production index(2004-2006) in Latin America(developing only) in 1971 to that in 1978?
Ensure brevity in your answer.  0.83. What is the ratio of the Production index(2004-2006) of Qatar in 1971 to that in 1978?
Your answer should be very brief. 0.88. What is the ratio of the Production index(2004-2006) of Singapore in 1971 to that in 1978?
Your answer should be very brief. 1.8. What is the ratio of the Production index(2004-2006) of South Africa in 1971 to that in 1978?
Give a very brief answer. 0.84. What is the ratio of the Production index(2004-2006) of Qatar in 1972 to that in 1973?
Keep it short and to the point. 170.24. What is the ratio of the Production index(2004-2006) of Singapore in 1972 to that in 1973?
Offer a terse response. 1.18. What is the ratio of the Production index(2004-2006) in South Africa in 1972 to that in 1973?
Your answer should be very brief. 1.3. What is the ratio of the Production index(2004-2006) of Latin America(developing only) in 1972 to that in 1974?
Your response must be concise. 0.94. What is the ratio of the Production index(2004-2006) in Qatar in 1972 to that in 1974?
Offer a terse response. 152.32. What is the ratio of the Production index(2004-2006) of Singapore in 1972 to that in 1974?
Your answer should be very brief. 1.58. What is the ratio of the Production index(2004-2006) in South Africa in 1972 to that in 1974?
Ensure brevity in your answer.  0.92. What is the ratio of the Production index(2004-2006) of Latin America(developing only) in 1972 to that in 1975?
Keep it short and to the point. 0.93. What is the ratio of the Production index(2004-2006) of Qatar in 1972 to that in 1975?
Make the answer very short. 144.7. What is the ratio of the Production index(2004-2006) in Singapore in 1972 to that in 1975?
Your response must be concise. 1.64. What is the ratio of the Production index(2004-2006) of South Africa in 1972 to that in 1975?
Ensure brevity in your answer.  0.99. What is the ratio of the Production index(2004-2006) in Latin America(developing only) in 1972 to that in 1976?
Make the answer very short. 0.92. What is the ratio of the Production index(2004-2006) of Qatar in 1972 to that in 1976?
Give a very brief answer. 80.39. What is the ratio of the Production index(2004-2006) in Singapore in 1972 to that in 1976?
Give a very brief answer. 1.51. What is the ratio of the Production index(2004-2006) of South Africa in 1972 to that in 1976?
Provide a short and direct response. 1.01. What is the ratio of the Production index(2004-2006) in Latin America(developing only) in 1972 to that in 1977?
Your answer should be compact. 0.85. What is the ratio of the Production index(2004-2006) in Qatar in 1972 to that in 1977?
Ensure brevity in your answer.  1.22. What is the ratio of the Production index(2004-2006) in Singapore in 1972 to that in 1977?
Your answer should be very brief. 1.68. What is the ratio of the Production index(2004-2006) in South Africa in 1972 to that in 1977?
Offer a very short reply. 0.94. What is the ratio of the Production index(2004-2006) of Latin America(developing only) in 1972 to that in 1978?
Your answer should be compact. 0.84. What is the ratio of the Production index(2004-2006) of Qatar in 1972 to that in 1978?
Offer a very short reply. 0.88. What is the ratio of the Production index(2004-2006) of Singapore in 1972 to that in 1978?
Make the answer very short. 1.82. What is the ratio of the Production index(2004-2006) in South Africa in 1972 to that in 1978?
Ensure brevity in your answer.  0.89. What is the ratio of the Production index(2004-2006) in Latin America(developing only) in 1973 to that in 1974?
Your response must be concise. 0.93. What is the ratio of the Production index(2004-2006) in Qatar in 1973 to that in 1974?
Give a very brief answer. 0.89. What is the ratio of the Production index(2004-2006) of Singapore in 1973 to that in 1974?
Make the answer very short. 1.33. What is the ratio of the Production index(2004-2006) of South Africa in 1973 to that in 1974?
Your answer should be compact. 0.71. What is the ratio of the Production index(2004-2006) of Latin America(developing only) in 1973 to that in 1975?
Your answer should be very brief. 0.93. What is the ratio of the Production index(2004-2006) in Qatar in 1973 to that in 1975?
Offer a terse response. 0.85. What is the ratio of the Production index(2004-2006) of Singapore in 1973 to that in 1975?
Offer a very short reply. 1.39. What is the ratio of the Production index(2004-2006) in South Africa in 1973 to that in 1975?
Your answer should be compact. 0.76. What is the ratio of the Production index(2004-2006) of Latin America(developing only) in 1973 to that in 1976?
Keep it short and to the point. 0.92. What is the ratio of the Production index(2004-2006) in Qatar in 1973 to that in 1976?
Offer a very short reply. 0.47. What is the ratio of the Production index(2004-2006) of Singapore in 1973 to that in 1976?
Provide a succinct answer. 1.28. What is the ratio of the Production index(2004-2006) of South Africa in 1973 to that in 1976?
Offer a very short reply. 0.78. What is the ratio of the Production index(2004-2006) of Latin America(developing only) in 1973 to that in 1977?
Offer a terse response. 0.85. What is the ratio of the Production index(2004-2006) of Qatar in 1973 to that in 1977?
Provide a short and direct response. 0.01. What is the ratio of the Production index(2004-2006) of Singapore in 1973 to that in 1977?
Provide a succinct answer. 1.42. What is the ratio of the Production index(2004-2006) of South Africa in 1973 to that in 1977?
Offer a terse response. 0.73. What is the ratio of the Production index(2004-2006) in Latin America(developing only) in 1973 to that in 1978?
Your response must be concise. 0.84. What is the ratio of the Production index(2004-2006) in Qatar in 1973 to that in 1978?
Give a very brief answer. 0.01. What is the ratio of the Production index(2004-2006) of Singapore in 1973 to that in 1978?
Give a very brief answer. 1.54. What is the ratio of the Production index(2004-2006) of South Africa in 1973 to that in 1978?
Offer a terse response. 0.68. What is the ratio of the Production index(2004-2006) of Latin America(developing only) in 1974 to that in 1975?
Your answer should be very brief. 1. What is the ratio of the Production index(2004-2006) of Singapore in 1974 to that in 1975?
Your response must be concise. 1.04. What is the ratio of the Production index(2004-2006) in South Africa in 1974 to that in 1975?
Your answer should be very brief. 1.08. What is the ratio of the Production index(2004-2006) of Latin America(developing only) in 1974 to that in 1976?
Give a very brief answer. 0.99. What is the ratio of the Production index(2004-2006) of Qatar in 1974 to that in 1976?
Offer a very short reply. 0.53. What is the ratio of the Production index(2004-2006) of Singapore in 1974 to that in 1976?
Offer a terse response. 0.96. What is the ratio of the Production index(2004-2006) of South Africa in 1974 to that in 1976?
Keep it short and to the point. 1.1. What is the ratio of the Production index(2004-2006) in Latin America(developing only) in 1974 to that in 1977?
Provide a short and direct response. 0.91. What is the ratio of the Production index(2004-2006) in Qatar in 1974 to that in 1977?
Your answer should be very brief. 0.01. What is the ratio of the Production index(2004-2006) of Singapore in 1974 to that in 1977?
Keep it short and to the point. 1.06. What is the ratio of the Production index(2004-2006) in South Africa in 1974 to that in 1977?
Ensure brevity in your answer.  1.03. What is the ratio of the Production index(2004-2006) in Latin America(developing only) in 1974 to that in 1978?
Provide a short and direct response. 0.9. What is the ratio of the Production index(2004-2006) of Qatar in 1974 to that in 1978?
Keep it short and to the point. 0.01. What is the ratio of the Production index(2004-2006) of Singapore in 1974 to that in 1978?
Offer a terse response. 1.16. What is the ratio of the Production index(2004-2006) in South Africa in 1974 to that in 1978?
Make the answer very short. 0.97. What is the ratio of the Production index(2004-2006) in Qatar in 1975 to that in 1976?
Ensure brevity in your answer.  0.56. What is the ratio of the Production index(2004-2006) in Singapore in 1975 to that in 1976?
Make the answer very short. 0.92. What is the ratio of the Production index(2004-2006) in South Africa in 1975 to that in 1976?
Your answer should be compact. 1.02. What is the ratio of the Production index(2004-2006) of Latin America(developing only) in 1975 to that in 1977?
Provide a short and direct response. 0.91. What is the ratio of the Production index(2004-2006) of Qatar in 1975 to that in 1977?
Give a very brief answer. 0.01. What is the ratio of the Production index(2004-2006) in Singapore in 1975 to that in 1977?
Make the answer very short. 1.02. What is the ratio of the Production index(2004-2006) of South Africa in 1975 to that in 1977?
Offer a terse response. 0.96. What is the ratio of the Production index(2004-2006) in Latin America(developing only) in 1975 to that in 1978?
Ensure brevity in your answer.  0.9. What is the ratio of the Production index(2004-2006) of Qatar in 1975 to that in 1978?
Your answer should be compact. 0.01. What is the ratio of the Production index(2004-2006) of Singapore in 1975 to that in 1978?
Make the answer very short. 1.11. What is the ratio of the Production index(2004-2006) in South Africa in 1975 to that in 1978?
Your response must be concise. 0.9. What is the ratio of the Production index(2004-2006) of Latin America(developing only) in 1976 to that in 1977?
Offer a very short reply. 0.92. What is the ratio of the Production index(2004-2006) of Qatar in 1976 to that in 1977?
Keep it short and to the point. 0.02. What is the ratio of the Production index(2004-2006) in Singapore in 1976 to that in 1977?
Keep it short and to the point. 1.11. What is the ratio of the Production index(2004-2006) of South Africa in 1976 to that in 1977?
Ensure brevity in your answer.  0.93. What is the ratio of the Production index(2004-2006) in Latin America(developing only) in 1976 to that in 1978?
Your answer should be very brief. 0.91. What is the ratio of the Production index(2004-2006) of Qatar in 1976 to that in 1978?
Your response must be concise. 0.01. What is the ratio of the Production index(2004-2006) in Singapore in 1976 to that in 1978?
Give a very brief answer. 1.2. What is the ratio of the Production index(2004-2006) of South Africa in 1976 to that in 1978?
Give a very brief answer. 0.88. What is the ratio of the Production index(2004-2006) in Qatar in 1977 to that in 1978?
Make the answer very short. 0.73. What is the ratio of the Production index(2004-2006) of Singapore in 1977 to that in 1978?
Make the answer very short. 1.09. What is the ratio of the Production index(2004-2006) of South Africa in 1977 to that in 1978?
Provide a succinct answer. 0.94. What is the difference between the highest and the second highest Production index(2004-2006) in Latin America(developing only)?
Offer a very short reply. 0.6. What is the difference between the highest and the second highest Production index(2004-2006) in Qatar?
Provide a succinct answer. 3.83. What is the difference between the highest and the second highest Production index(2004-2006) of Singapore?
Make the answer very short. 6.91. What is the difference between the highest and the second highest Production index(2004-2006) in South Africa?
Ensure brevity in your answer.  2.49. What is the difference between the highest and the lowest Production index(2004-2006) of Latin America(developing only)?
Give a very brief answer. 8.34. What is the difference between the highest and the lowest Production index(2004-2006) in Qatar?
Make the answer very short. 32.6. What is the difference between the highest and the lowest Production index(2004-2006) in Singapore?
Your response must be concise. 299.63. What is the difference between the highest and the lowest Production index(2004-2006) in South Africa?
Give a very brief answer. 24.09. 